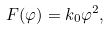<formula> <loc_0><loc_0><loc_500><loc_500>F ( \varphi ) = k _ { 0 } \varphi ^ { 2 } ,</formula> 